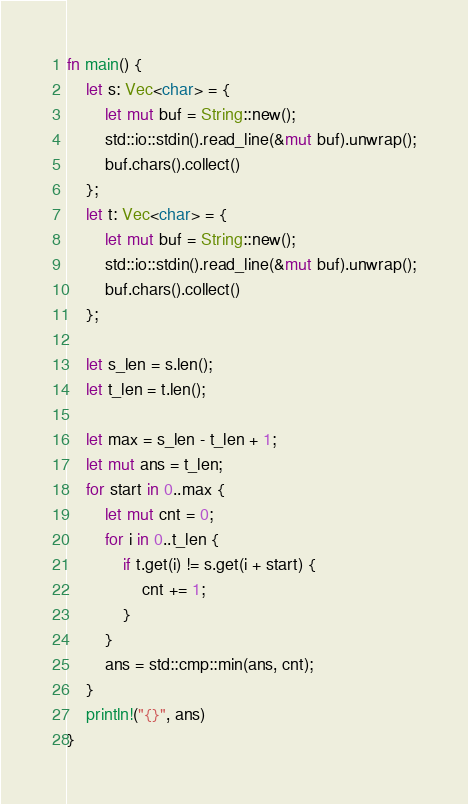<code> <loc_0><loc_0><loc_500><loc_500><_Rust_>fn main() {
    let s: Vec<char> = {
        let mut buf = String::new();
        std::io::stdin().read_line(&mut buf).unwrap();
        buf.chars().collect()
    };
    let t: Vec<char> = {
        let mut buf = String::new();
        std::io::stdin().read_line(&mut buf).unwrap();
        buf.chars().collect()
    };

    let s_len = s.len();
    let t_len = t.len();

    let max = s_len - t_len + 1;
    let mut ans = t_len;
    for start in 0..max {
        let mut cnt = 0;
        for i in 0..t_len {
            if t.get(i) != s.get(i + start) {
                cnt += 1;
            }
        }
        ans = std::cmp::min(ans, cnt);
    }
    println!("{}", ans)
}
</code> 